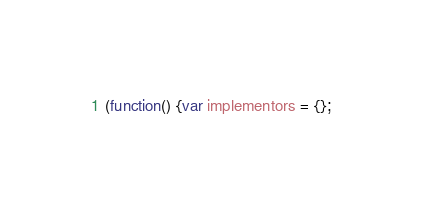Convert code to text. <code><loc_0><loc_0><loc_500><loc_500><_JavaScript_>(function() {var implementors = {};</code> 